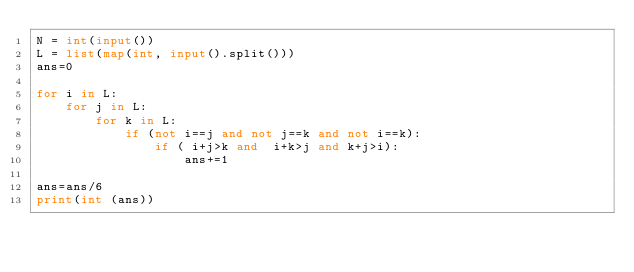<code> <loc_0><loc_0><loc_500><loc_500><_Python_>N = int(input())
L = list(map(int, input().split()))
ans=0

for i in L:
    for j in L:
        for k in L:
            if (not i==j and not j==k and not i==k):
                if ( i+j>k and  i+k>j and k+j>i):
                    ans+=1

ans=ans/6
print(int (ans))
</code> 